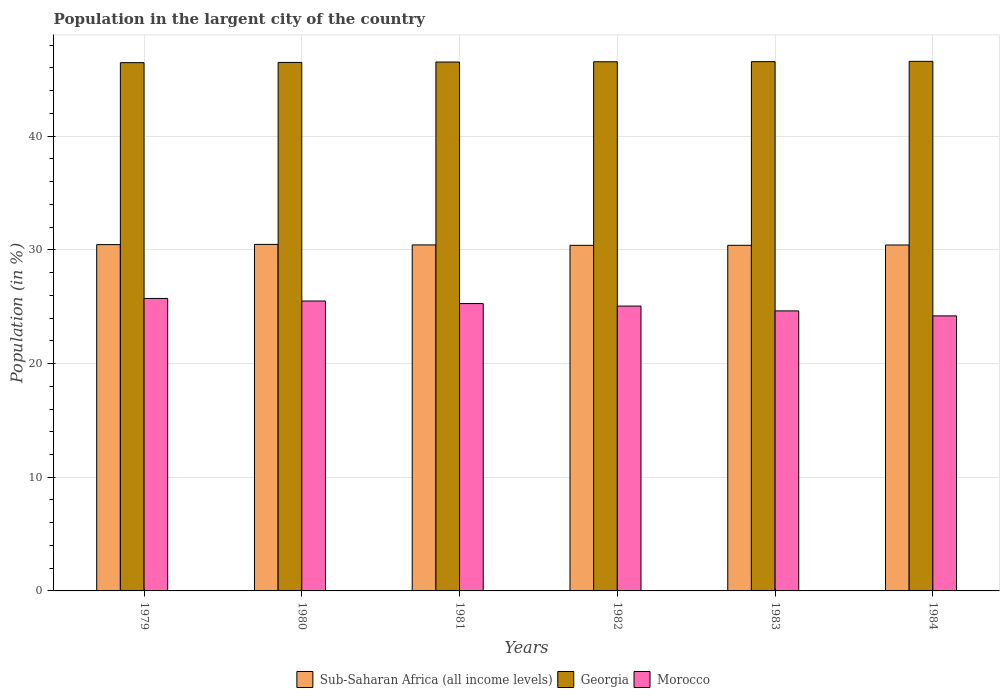How many different coloured bars are there?
Offer a terse response. 3. How many groups of bars are there?
Your answer should be very brief. 6. Are the number of bars per tick equal to the number of legend labels?
Keep it short and to the point. Yes. Are the number of bars on each tick of the X-axis equal?
Make the answer very short. Yes. How many bars are there on the 4th tick from the right?
Your answer should be very brief. 3. What is the percentage of population in the largent city in Georgia in 1981?
Your response must be concise. 46.52. Across all years, what is the maximum percentage of population in the largent city in Morocco?
Offer a very short reply. 25.72. Across all years, what is the minimum percentage of population in the largent city in Sub-Saharan Africa (all income levels)?
Make the answer very short. 30.39. In which year was the percentage of population in the largent city in Morocco maximum?
Ensure brevity in your answer.  1979. In which year was the percentage of population in the largent city in Morocco minimum?
Your answer should be very brief. 1984. What is the total percentage of population in the largent city in Morocco in the graph?
Your answer should be compact. 150.36. What is the difference between the percentage of population in the largent city in Sub-Saharan Africa (all income levels) in 1979 and that in 1981?
Your answer should be compact. 0.03. What is the difference between the percentage of population in the largent city in Morocco in 1979 and the percentage of population in the largent city in Georgia in 1980?
Your answer should be compact. -20.76. What is the average percentage of population in the largent city in Morocco per year?
Make the answer very short. 25.06. In the year 1981, what is the difference between the percentage of population in the largent city in Morocco and percentage of population in the largent city in Georgia?
Your answer should be very brief. -21.24. What is the ratio of the percentage of population in the largent city in Sub-Saharan Africa (all income levels) in 1980 to that in 1982?
Provide a short and direct response. 1. Is the percentage of population in the largent city in Georgia in 1979 less than that in 1981?
Your response must be concise. Yes. What is the difference between the highest and the second highest percentage of population in the largent city in Sub-Saharan Africa (all income levels)?
Offer a terse response. 0.02. What is the difference between the highest and the lowest percentage of population in the largent city in Sub-Saharan Africa (all income levels)?
Offer a very short reply. 0.08. Is the sum of the percentage of population in the largent city in Morocco in 1979 and 1984 greater than the maximum percentage of population in the largent city in Sub-Saharan Africa (all income levels) across all years?
Provide a short and direct response. Yes. What does the 2nd bar from the left in 1981 represents?
Your answer should be compact. Georgia. What does the 2nd bar from the right in 1984 represents?
Ensure brevity in your answer.  Georgia. Is it the case that in every year, the sum of the percentage of population in the largent city in Sub-Saharan Africa (all income levels) and percentage of population in the largent city in Georgia is greater than the percentage of population in the largent city in Morocco?
Offer a very short reply. Yes. How many years are there in the graph?
Your answer should be compact. 6. Are the values on the major ticks of Y-axis written in scientific E-notation?
Offer a terse response. No. Does the graph contain any zero values?
Offer a very short reply. No. How are the legend labels stacked?
Your answer should be very brief. Horizontal. What is the title of the graph?
Provide a short and direct response. Population in the largent city of the country. What is the label or title of the X-axis?
Offer a terse response. Years. What is the Population (in %) in Sub-Saharan Africa (all income levels) in 1979?
Provide a short and direct response. 30.46. What is the Population (in %) in Georgia in 1979?
Make the answer very short. 46.46. What is the Population (in %) of Morocco in 1979?
Your response must be concise. 25.72. What is the Population (in %) of Sub-Saharan Africa (all income levels) in 1980?
Provide a short and direct response. 30.48. What is the Population (in %) in Georgia in 1980?
Ensure brevity in your answer.  46.48. What is the Population (in %) of Morocco in 1980?
Your response must be concise. 25.5. What is the Population (in %) in Sub-Saharan Africa (all income levels) in 1981?
Give a very brief answer. 30.43. What is the Population (in %) in Georgia in 1981?
Give a very brief answer. 46.52. What is the Population (in %) in Morocco in 1981?
Make the answer very short. 25.27. What is the Population (in %) in Sub-Saharan Africa (all income levels) in 1982?
Ensure brevity in your answer.  30.39. What is the Population (in %) in Georgia in 1982?
Offer a terse response. 46.54. What is the Population (in %) of Morocco in 1982?
Make the answer very short. 25.05. What is the Population (in %) in Sub-Saharan Africa (all income levels) in 1983?
Your answer should be very brief. 30.4. What is the Population (in %) of Georgia in 1983?
Provide a short and direct response. 46.55. What is the Population (in %) in Morocco in 1983?
Your response must be concise. 24.63. What is the Population (in %) in Sub-Saharan Africa (all income levels) in 1984?
Make the answer very short. 30.42. What is the Population (in %) in Georgia in 1984?
Give a very brief answer. 46.58. What is the Population (in %) in Morocco in 1984?
Your answer should be very brief. 24.19. Across all years, what is the maximum Population (in %) in Sub-Saharan Africa (all income levels)?
Offer a terse response. 30.48. Across all years, what is the maximum Population (in %) in Georgia?
Make the answer very short. 46.58. Across all years, what is the maximum Population (in %) in Morocco?
Make the answer very short. 25.72. Across all years, what is the minimum Population (in %) of Sub-Saharan Africa (all income levels)?
Your answer should be compact. 30.39. Across all years, what is the minimum Population (in %) in Georgia?
Give a very brief answer. 46.46. Across all years, what is the minimum Population (in %) of Morocco?
Keep it short and to the point. 24.19. What is the total Population (in %) of Sub-Saharan Africa (all income levels) in the graph?
Offer a terse response. 182.58. What is the total Population (in %) of Georgia in the graph?
Offer a very short reply. 279.12. What is the total Population (in %) in Morocco in the graph?
Your answer should be compact. 150.37. What is the difference between the Population (in %) of Sub-Saharan Africa (all income levels) in 1979 and that in 1980?
Offer a very short reply. -0.02. What is the difference between the Population (in %) of Georgia in 1979 and that in 1980?
Keep it short and to the point. -0.02. What is the difference between the Population (in %) of Morocco in 1979 and that in 1980?
Provide a short and direct response. 0.23. What is the difference between the Population (in %) in Sub-Saharan Africa (all income levels) in 1979 and that in 1981?
Provide a short and direct response. 0.03. What is the difference between the Population (in %) in Georgia in 1979 and that in 1981?
Make the answer very short. -0.06. What is the difference between the Population (in %) in Morocco in 1979 and that in 1981?
Provide a succinct answer. 0.45. What is the difference between the Population (in %) of Sub-Saharan Africa (all income levels) in 1979 and that in 1982?
Ensure brevity in your answer.  0.06. What is the difference between the Population (in %) in Georgia in 1979 and that in 1982?
Give a very brief answer. -0.08. What is the difference between the Population (in %) of Morocco in 1979 and that in 1982?
Your answer should be very brief. 0.67. What is the difference between the Population (in %) in Georgia in 1979 and that in 1983?
Give a very brief answer. -0.09. What is the difference between the Population (in %) of Morocco in 1979 and that in 1983?
Your answer should be very brief. 1.09. What is the difference between the Population (in %) in Sub-Saharan Africa (all income levels) in 1979 and that in 1984?
Offer a very short reply. 0.03. What is the difference between the Population (in %) in Georgia in 1979 and that in 1984?
Your answer should be very brief. -0.11. What is the difference between the Population (in %) in Morocco in 1979 and that in 1984?
Provide a short and direct response. 1.53. What is the difference between the Population (in %) in Sub-Saharan Africa (all income levels) in 1980 and that in 1981?
Ensure brevity in your answer.  0.04. What is the difference between the Population (in %) in Georgia in 1980 and that in 1981?
Provide a succinct answer. -0.03. What is the difference between the Population (in %) in Morocco in 1980 and that in 1981?
Give a very brief answer. 0.23. What is the difference between the Population (in %) of Sub-Saharan Africa (all income levels) in 1980 and that in 1982?
Make the answer very short. 0.08. What is the difference between the Population (in %) in Georgia in 1980 and that in 1982?
Your answer should be compact. -0.06. What is the difference between the Population (in %) of Morocco in 1980 and that in 1982?
Provide a short and direct response. 0.44. What is the difference between the Population (in %) of Sub-Saharan Africa (all income levels) in 1980 and that in 1983?
Make the answer very short. 0.08. What is the difference between the Population (in %) of Georgia in 1980 and that in 1983?
Keep it short and to the point. -0.07. What is the difference between the Population (in %) of Morocco in 1980 and that in 1983?
Your answer should be compact. 0.87. What is the difference between the Population (in %) in Sub-Saharan Africa (all income levels) in 1980 and that in 1984?
Your response must be concise. 0.05. What is the difference between the Population (in %) in Georgia in 1980 and that in 1984?
Give a very brief answer. -0.09. What is the difference between the Population (in %) in Morocco in 1980 and that in 1984?
Provide a succinct answer. 1.31. What is the difference between the Population (in %) of Sub-Saharan Africa (all income levels) in 1981 and that in 1982?
Keep it short and to the point. 0.04. What is the difference between the Population (in %) of Georgia in 1981 and that in 1982?
Offer a very short reply. -0.02. What is the difference between the Population (in %) of Morocco in 1981 and that in 1982?
Offer a terse response. 0.22. What is the difference between the Population (in %) of Sub-Saharan Africa (all income levels) in 1981 and that in 1983?
Offer a terse response. 0.03. What is the difference between the Population (in %) of Georgia in 1981 and that in 1983?
Ensure brevity in your answer.  -0.03. What is the difference between the Population (in %) in Morocco in 1981 and that in 1983?
Keep it short and to the point. 0.64. What is the difference between the Population (in %) in Sub-Saharan Africa (all income levels) in 1981 and that in 1984?
Offer a terse response. 0.01. What is the difference between the Population (in %) in Georgia in 1981 and that in 1984?
Your answer should be very brief. -0.06. What is the difference between the Population (in %) of Morocco in 1981 and that in 1984?
Offer a terse response. 1.08. What is the difference between the Population (in %) in Sub-Saharan Africa (all income levels) in 1982 and that in 1983?
Offer a terse response. -0. What is the difference between the Population (in %) of Georgia in 1982 and that in 1983?
Provide a short and direct response. -0.01. What is the difference between the Population (in %) of Morocco in 1982 and that in 1983?
Make the answer very short. 0.42. What is the difference between the Population (in %) in Sub-Saharan Africa (all income levels) in 1982 and that in 1984?
Your answer should be compact. -0.03. What is the difference between the Population (in %) in Georgia in 1982 and that in 1984?
Your answer should be compact. -0.04. What is the difference between the Population (in %) of Morocco in 1982 and that in 1984?
Offer a very short reply. 0.86. What is the difference between the Population (in %) of Sub-Saharan Africa (all income levels) in 1983 and that in 1984?
Keep it short and to the point. -0.03. What is the difference between the Population (in %) in Georgia in 1983 and that in 1984?
Give a very brief answer. -0.03. What is the difference between the Population (in %) in Morocco in 1983 and that in 1984?
Give a very brief answer. 0.44. What is the difference between the Population (in %) of Sub-Saharan Africa (all income levels) in 1979 and the Population (in %) of Georgia in 1980?
Ensure brevity in your answer.  -16.02. What is the difference between the Population (in %) of Sub-Saharan Africa (all income levels) in 1979 and the Population (in %) of Morocco in 1980?
Offer a very short reply. 4.96. What is the difference between the Population (in %) of Georgia in 1979 and the Population (in %) of Morocco in 1980?
Provide a short and direct response. 20.96. What is the difference between the Population (in %) in Sub-Saharan Africa (all income levels) in 1979 and the Population (in %) in Georgia in 1981?
Give a very brief answer. -16.06. What is the difference between the Population (in %) in Sub-Saharan Africa (all income levels) in 1979 and the Population (in %) in Morocco in 1981?
Your answer should be very brief. 5.19. What is the difference between the Population (in %) in Georgia in 1979 and the Population (in %) in Morocco in 1981?
Provide a succinct answer. 21.19. What is the difference between the Population (in %) in Sub-Saharan Africa (all income levels) in 1979 and the Population (in %) in Georgia in 1982?
Make the answer very short. -16.08. What is the difference between the Population (in %) of Sub-Saharan Africa (all income levels) in 1979 and the Population (in %) of Morocco in 1982?
Ensure brevity in your answer.  5.4. What is the difference between the Population (in %) in Georgia in 1979 and the Population (in %) in Morocco in 1982?
Give a very brief answer. 21.41. What is the difference between the Population (in %) in Sub-Saharan Africa (all income levels) in 1979 and the Population (in %) in Georgia in 1983?
Provide a succinct answer. -16.09. What is the difference between the Population (in %) in Sub-Saharan Africa (all income levels) in 1979 and the Population (in %) in Morocco in 1983?
Give a very brief answer. 5.83. What is the difference between the Population (in %) of Georgia in 1979 and the Population (in %) of Morocco in 1983?
Give a very brief answer. 21.83. What is the difference between the Population (in %) of Sub-Saharan Africa (all income levels) in 1979 and the Population (in %) of Georgia in 1984?
Keep it short and to the point. -16.12. What is the difference between the Population (in %) in Sub-Saharan Africa (all income levels) in 1979 and the Population (in %) in Morocco in 1984?
Provide a succinct answer. 6.27. What is the difference between the Population (in %) of Georgia in 1979 and the Population (in %) of Morocco in 1984?
Offer a terse response. 22.27. What is the difference between the Population (in %) of Sub-Saharan Africa (all income levels) in 1980 and the Population (in %) of Georgia in 1981?
Ensure brevity in your answer.  -16.04. What is the difference between the Population (in %) in Sub-Saharan Africa (all income levels) in 1980 and the Population (in %) in Morocco in 1981?
Keep it short and to the point. 5.2. What is the difference between the Population (in %) in Georgia in 1980 and the Population (in %) in Morocco in 1981?
Keep it short and to the point. 21.21. What is the difference between the Population (in %) in Sub-Saharan Africa (all income levels) in 1980 and the Population (in %) in Georgia in 1982?
Offer a terse response. -16.06. What is the difference between the Population (in %) in Sub-Saharan Africa (all income levels) in 1980 and the Population (in %) in Morocco in 1982?
Your response must be concise. 5.42. What is the difference between the Population (in %) of Georgia in 1980 and the Population (in %) of Morocco in 1982?
Your response must be concise. 21.43. What is the difference between the Population (in %) of Sub-Saharan Africa (all income levels) in 1980 and the Population (in %) of Georgia in 1983?
Ensure brevity in your answer.  -16.07. What is the difference between the Population (in %) in Sub-Saharan Africa (all income levels) in 1980 and the Population (in %) in Morocco in 1983?
Your answer should be compact. 5.85. What is the difference between the Population (in %) in Georgia in 1980 and the Population (in %) in Morocco in 1983?
Your answer should be compact. 21.85. What is the difference between the Population (in %) of Sub-Saharan Africa (all income levels) in 1980 and the Population (in %) of Georgia in 1984?
Offer a terse response. -16.1. What is the difference between the Population (in %) in Sub-Saharan Africa (all income levels) in 1980 and the Population (in %) in Morocco in 1984?
Give a very brief answer. 6.29. What is the difference between the Population (in %) of Georgia in 1980 and the Population (in %) of Morocco in 1984?
Offer a very short reply. 22.29. What is the difference between the Population (in %) in Sub-Saharan Africa (all income levels) in 1981 and the Population (in %) in Georgia in 1982?
Ensure brevity in your answer.  -16.11. What is the difference between the Population (in %) of Sub-Saharan Africa (all income levels) in 1981 and the Population (in %) of Morocco in 1982?
Your answer should be very brief. 5.38. What is the difference between the Population (in %) in Georgia in 1981 and the Population (in %) in Morocco in 1982?
Your response must be concise. 21.46. What is the difference between the Population (in %) of Sub-Saharan Africa (all income levels) in 1981 and the Population (in %) of Georgia in 1983?
Your response must be concise. -16.12. What is the difference between the Population (in %) in Sub-Saharan Africa (all income levels) in 1981 and the Population (in %) in Morocco in 1983?
Ensure brevity in your answer.  5.8. What is the difference between the Population (in %) in Georgia in 1981 and the Population (in %) in Morocco in 1983?
Your answer should be compact. 21.89. What is the difference between the Population (in %) of Sub-Saharan Africa (all income levels) in 1981 and the Population (in %) of Georgia in 1984?
Make the answer very short. -16.14. What is the difference between the Population (in %) of Sub-Saharan Africa (all income levels) in 1981 and the Population (in %) of Morocco in 1984?
Give a very brief answer. 6.24. What is the difference between the Population (in %) in Georgia in 1981 and the Population (in %) in Morocco in 1984?
Provide a short and direct response. 22.33. What is the difference between the Population (in %) of Sub-Saharan Africa (all income levels) in 1982 and the Population (in %) of Georgia in 1983?
Your answer should be very brief. -16.16. What is the difference between the Population (in %) in Sub-Saharan Africa (all income levels) in 1982 and the Population (in %) in Morocco in 1983?
Offer a terse response. 5.77. What is the difference between the Population (in %) of Georgia in 1982 and the Population (in %) of Morocco in 1983?
Offer a very short reply. 21.91. What is the difference between the Population (in %) in Sub-Saharan Africa (all income levels) in 1982 and the Population (in %) in Georgia in 1984?
Keep it short and to the point. -16.18. What is the difference between the Population (in %) in Sub-Saharan Africa (all income levels) in 1982 and the Population (in %) in Morocco in 1984?
Provide a succinct answer. 6.21. What is the difference between the Population (in %) in Georgia in 1982 and the Population (in %) in Morocco in 1984?
Offer a very short reply. 22.35. What is the difference between the Population (in %) in Sub-Saharan Africa (all income levels) in 1983 and the Population (in %) in Georgia in 1984?
Ensure brevity in your answer.  -16.18. What is the difference between the Population (in %) in Sub-Saharan Africa (all income levels) in 1983 and the Population (in %) in Morocco in 1984?
Keep it short and to the point. 6.21. What is the difference between the Population (in %) of Georgia in 1983 and the Population (in %) of Morocco in 1984?
Keep it short and to the point. 22.36. What is the average Population (in %) in Sub-Saharan Africa (all income levels) per year?
Your answer should be very brief. 30.43. What is the average Population (in %) of Georgia per year?
Provide a short and direct response. 46.52. What is the average Population (in %) in Morocco per year?
Offer a terse response. 25.06. In the year 1979, what is the difference between the Population (in %) in Sub-Saharan Africa (all income levels) and Population (in %) in Georgia?
Make the answer very short. -16. In the year 1979, what is the difference between the Population (in %) of Sub-Saharan Africa (all income levels) and Population (in %) of Morocco?
Provide a short and direct response. 4.73. In the year 1979, what is the difference between the Population (in %) in Georgia and Population (in %) in Morocco?
Your answer should be very brief. 20.74. In the year 1980, what is the difference between the Population (in %) in Sub-Saharan Africa (all income levels) and Population (in %) in Georgia?
Make the answer very short. -16.01. In the year 1980, what is the difference between the Population (in %) of Sub-Saharan Africa (all income levels) and Population (in %) of Morocco?
Give a very brief answer. 4.98. In the year 1980, what is the difference between the Population (in %) in Georgia and Population (in %) in Morocco?
Offer a terse response. 20.98. In the year 1981, what is the difference between the Population (in %) in Sub-Saharan Africa (all income levels) and Population (in %) in Georgia?
Offer a very short reply. -16.08. In the year 1981, what is the difference between the Population (in %) of Sub-Saharan Africa (all income levels) and Population (in %) of Morocco?
Keep it short and to the point. 5.16. In the year 1981, what is the difference between the Population (in %) of Georgia and Population (in %) of Morocco?
Offer a terse response. 21.24. In the year 1982, what is the difference between the Population (in %) in Sub-Saharan Africa (all income levels) and Population (in %) in Georgia?
Ensure brevity in your answer.  -16.14. In the year 1982, what is the difference between the Population (in %) in Sub-Saharan Africa (all income levels) and Population (in %) in Morocco?
Offer a terse response. 5.34. In the year 1982, what is the difference between the Population (in %) in Georgia and Population (in %) in Morocco?
Keep it short and to the point. 21.49. In the year 1983, what is the difference between the Population (in %) of Sub-Saharan Africa (all income levels) and Population (in %) of Georgia?
Your answer should be compact. -16.15. In the year 1983, what is the difference between the Population (in %) of Sub-Saharan Africa (all income levels) and Population (in %) of Morocco?
Offer a very short reply. 5.77. In the year 1983, what is the difference between the Population (in %) of Georgia and Population (in %) of Morocco?
Make the answer very short. 21.92. In the year 1984, what is the difference between the Population (in %) of Sub-Saharan Africa (all income levels) and Population (in %) of Georgia?
Give a very brief answer. -16.15. In the year 1984, what is the difference between the Population (in %) in Sub-Saharan Africa (all income levels) and Population (in %) in Morocco?
Your answer should be compact. 6.24. In the year 1984, what is the difference between the Population (in %) in Georgia and Population (in %) in Morocco?
Provide a short and direct response. 22.39. What is the ratio of the Population (in %) in Morocco in 1979 to that in 1980?
Your answer should be very brief. 1.01. What is the ratio of the Population (in %) of Morocco in 1979 to that in 1981?
Give a very brief answer. 1.02. What is the ratio of the Population (in %) of Sub-Saharan Africa (all income levels) in 1979 to that in 1982?
Ensure brevity in your answer.  1. What is the ratio of the Population (in %) of Georgia in 1979 to that in 1982?
Provide a succinct answer. 1. What is the ratio of the Population (in %) of Morocco in 1979 to that in 1982?
Ensure brevity in your answer.  1.03. What is the ratio of the Population (in %) in Morocco in 1979 to that in 1983?
Offer a very short reply. 1.04. What is the ratio of the Population (in %) in Morocco in 1979 to that in 1984?
Your answer should be compact. 1.06. What is the ratio of the Population (in %) of Sub-Saharan Africa (all income levels) in 1980 to that in 1981?
Provide a short and direct response. 1. What is the ratio of the Population (in %) in Morocco in 1980 to that in 1981?
Your response must be concise. 1.01. What is the ratio of the Population (in %) of Georgia in 1980 to that in 1982?
Keep it short and to the point. 1. What is the ratio of the Population (in %) of Morocco in 1980 to that in 1982?
Your response must be concise. 1.02. What is the ratio of the Population (in %) of Morocco in 1980 to that in 1983?
Keep it short and to the point. 1.04. What is the ratio of the Population (in %) in Morocco in 1980 to that in 1984?
Your answer should be very brief. 1.05. What is the ratio of the Population (in %) in Morocco in 1981 to that in 1982?
Offer a very short reply. 1.01. What is the ratio of the Population (in %) of Sub-Saharan Africa (all income levels) in 1981 to that in 1983?
Ensure brevity in your answer.  1. What is the ratio of the Population (in %) in Morocco in 1981 to that in 1983?
Ensure brevity in your answer.  1.03. What is the ratio of the Population (in %) of Georgia in 1981 to that in 1984?
Provide a succinct answer. 1. What is the ratio of the Population (in %) in Morocco in 1981 to that in 1984?
Offer a very short reply. 1.04. What is the ratio of the Population (in %) of Georgia in 1982 to that in 1983?
Ensure brevity in your answer.  1. What is the ratio of the Population (in %) in Morocco in 1982 to that in 1983?
Offer a terse response. 1.02. What is the ratio of the Population (in %) of Morocco in 1982 to that in 1984?
Make the answer very short. 1.04. What is the ratio of the Population (in %) in Georgia in 1983 to that in 1984?
Your answer should be compact. 1. What is the ratio of the Population (in %) of Morocco in 1983 to that in 1984?
Provide a short and direct response. 1.02. What is the difference between the highest and the second highest Population (in %) in Sub-Saharan Africa (all income levels)?
Keep it short and to the point. 0.02. What is the difference between the highest and the second highest Population (in %) in Georgia?
Offer a very short reply. 0.03. What is the difference between the highest and the second highest Population (in %) of Morocco?
Provide a short and direct response. 0.23. What is the difference between the highest and the lowest Population (in %) in Sub-Saharan Africa (all income levels)?
Your answer should be very brief. 0.08. What is the difference between the highest and the lowest Population (in %) in Georgia?
Offer a very short reply. 0.11. What is the difference between the highest and the lowest Population (in %) in Morocco?
Provide a short and direct response. 1.53. 